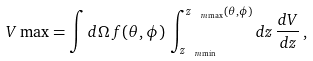<formula> <loc_0><loc_0><loc_500><loc_500>\ V \max = \int d \Omega \, f ( \theta , \phi ) \, \int _ { z _ { \ m \min } } ^ { z _ { \ m \max } ( \theta , \phi ) } d z \, \frac { d V } { d z } \, ,</formula> 